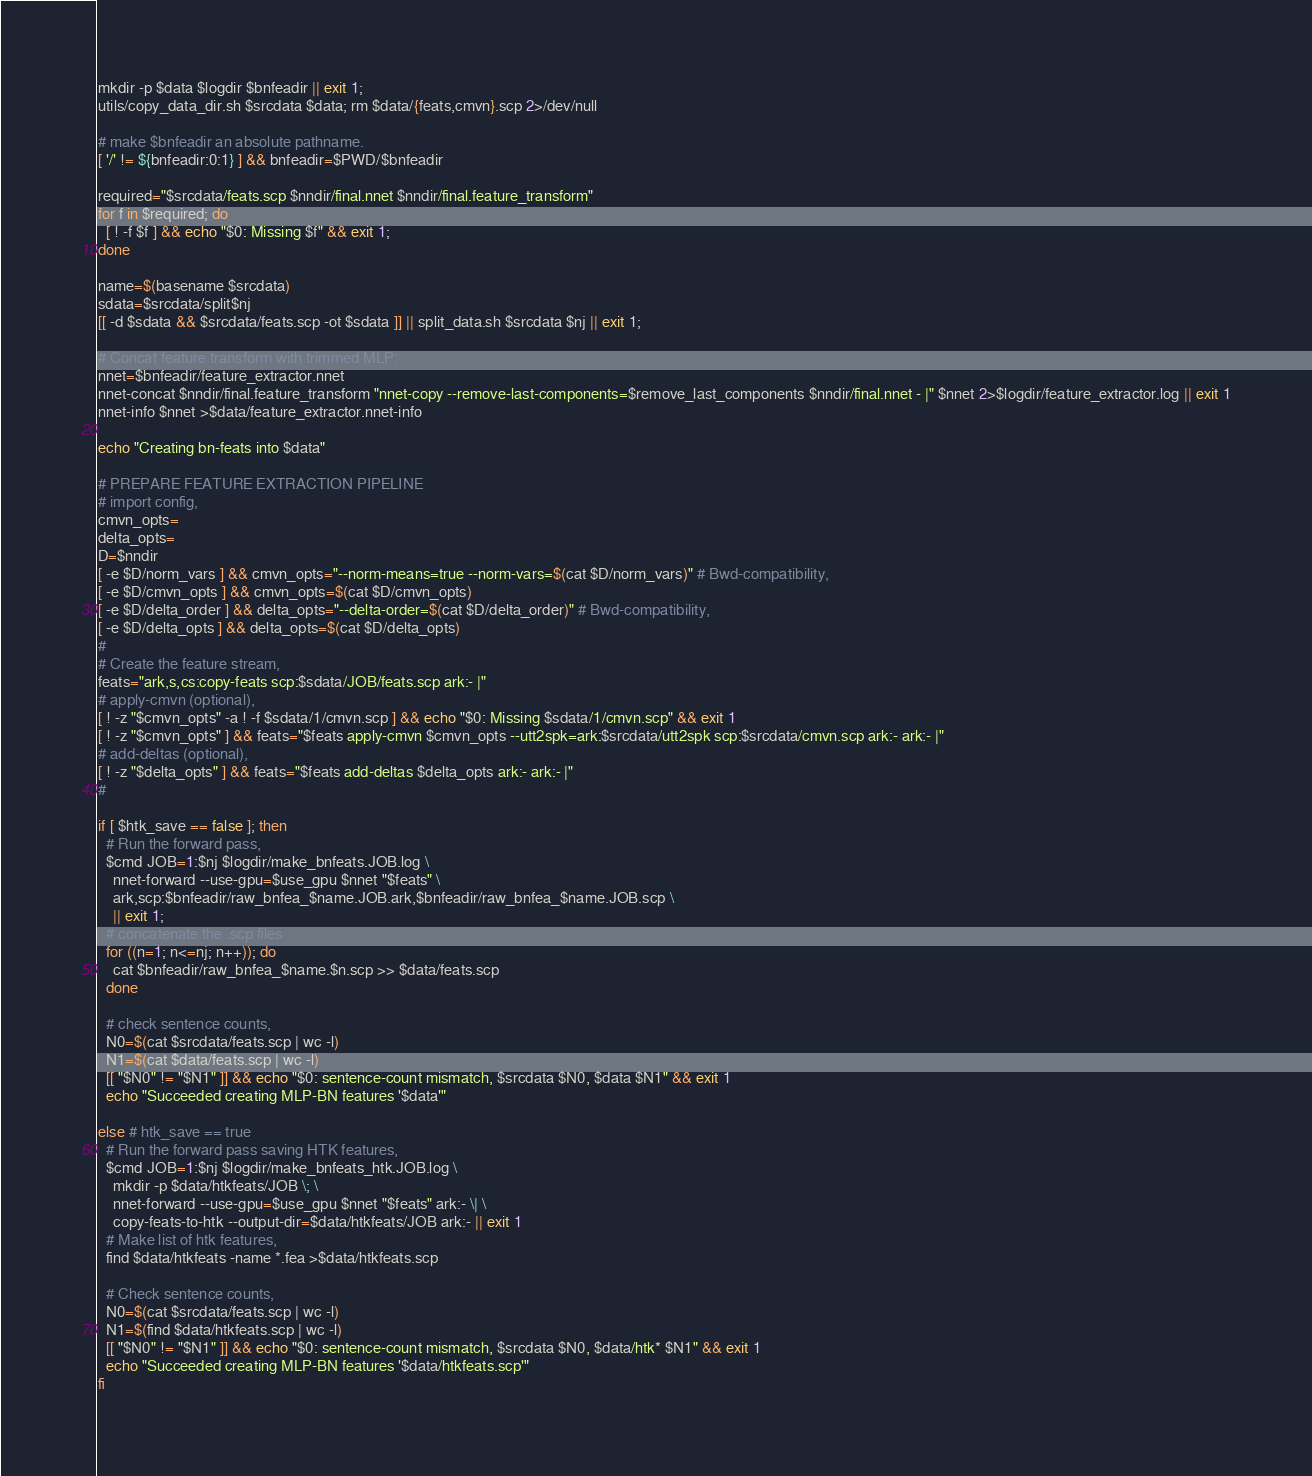<code> <loc_0><loc_0><loc_500><loc_500><_Bash_>mkdir -p $data $logdir $bnfeadir || exit 1;
utils/copy_data_dir.sh $srcdata $data; rm $data/{feats,cmvn}.scp 2>/dev/null

# make $bnfeadir an absolute pathname.
[ '/' != ${bnfeadir:0:1} ] && bnfeadir=$PWD/$bnfeadir

required="$srcdata/feats.scp $nndir/final.nnet $nndir/final.feature_transform"
for f in $required; do
  [ ! -f $f ] && echo "$0: Missing $f" && exit 1;
done

name=$(basename $srcdata)
sdata=$srcdata/split$nj
[[ -d $sdata && $srcdata/feats.scp -ot $sdata ]] || split_data.sh $srcdata $nj || exit 1;

# Concat feature transform with trimmed MLP:
nnet=$bnfeadir/feature_extractor.nnet
nnet-concat $nndir/final.feature_transform "nnet-copy --remove-last-components=$remove_last_components $nndir/final.nnet - |" $nnet 2>$logdir/feature_extractor.log || exit 1
nnet-info $nnet >$data/feature_extractor.nnet-info

echo "Creating bn-feats into $data"

# PREPARE FEATURE EXTRACTION PIPELINE
# import config,
cmvn_opts=
delta_opts=
D=$nndir
[ -e $D/norm_vars ] && cmvn_opts="--norm-means=true --norm-vars=$(cat $D/norm_vars)" # Bwd-compatibility,
[ -e $D/cmvn_opts ] && cmvn_opts=$(cat $D/cmvn_opts)
[ -e $D/delta_order ] && delta_opts="--delta-order=$(cat $D/delta_order)" # Bwd-compatibility,
[ -e $D/delta_opts ] && delta_opts=$(cat $D/delta_opts)
#
# Create the feature stream,
feats="ark,s,cs:copy-feats scp:$sdata/JOB/feats.scp ark:- |"
# apply-cmvn (optional),
[ ! -z "$cmvn_opts" -a ! -f $sdata/1/cmvn.scp ] && echo "$0: Missing $sdata/1/cmvn.scp" && exit 1
[ ! -z "$cmvn_opts" ] && feats="$feats apply-cmvn $cmvn_opts --utt2spk=ark:$srcdata/utt2spk scp:$srcdata/cmvn.scp ark:- ark:- |"
# add-deltas (optional),
[ ! -z "$delta_opts" ] && feats="$feats add-deltas $delta_opts ark:- ark:- |"
#

if [ $htk_save == false ]; then
  # Run the forward pass,
  $cmd JOB=1:$nj $logdir/make_bnfeats.JOB.log \
    nnet-forward --use-gpu=$use_gpu $nnet "$feats" \
    ark,scp:$bnfeadir/raw_bnfea_$name.JOB.ark,$bnfeadir/raw_bnfea_$name.JOB.scp \
    || exit 1;
  # concatenate the .scp files
  for ((n=1; n<=nj; n++)); do
    cat $bnfeadir/raw_bnfea_$name.$n.scp >> $data/feats.scp
  done

  # check sentence counts,
  N0=$(cat $srcdata/feats.scp | wc -l) 
  N1=$(cat $data/feats.scp | wc -l)
  [[ "$N0" != "$N1" ]] && echo "$0: sentence-count mismatch, $srcdata $N0, $data $N1" && exit 1
  echo "Succeeded creating MLP-BN features '$data'"

else # htk_save == true
  # Run the forward pass saving HTK features,
  $cmd JOB=1:$nj $logdir/make_bnfeats_htk.JOB.log \
    mkdir -p $data/htkfeats/JOB \; \
    nnet-forward --use-gpu=$use_gpu $nnet "$feats" ark:- \| \
    copy-feats-to-htk --output-dir=$data/htkfeats/JOB ark:- || exit 1
  # Make list of htk features,
  find $data/htkfeats -name *.fea >$data/htkfeats.scp

  # Check sentence counts,
  N0=$(cat $srcdata/feats.scp | wc -l)
  N1=$(find $data/htkfeats.scp | wc -l)
  [[ "$N0" != "$N1" ]] && echo "$0: sentence-count mismatch, $srcdata $N0, $data/htk* $N1" && exit 1
  echo "Succeeded creating MLP-BN features '$data/htkfeats.scp'"
fi
</code> 